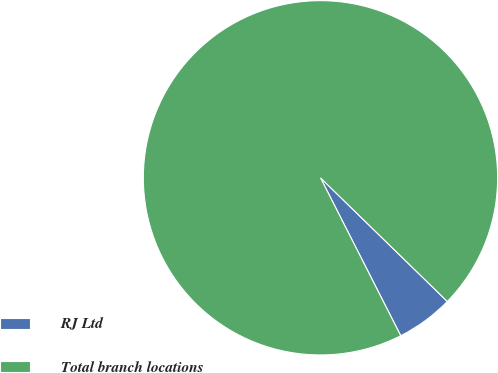Convert chart to OTSL. <chart><loc_0><loc_0><loc_500><loc_500><pie_chart><fcel>RJ Ltd<fcel>Total branch locations<nl><fcel>5.22%<fcel>94.78%<nl></chart> 